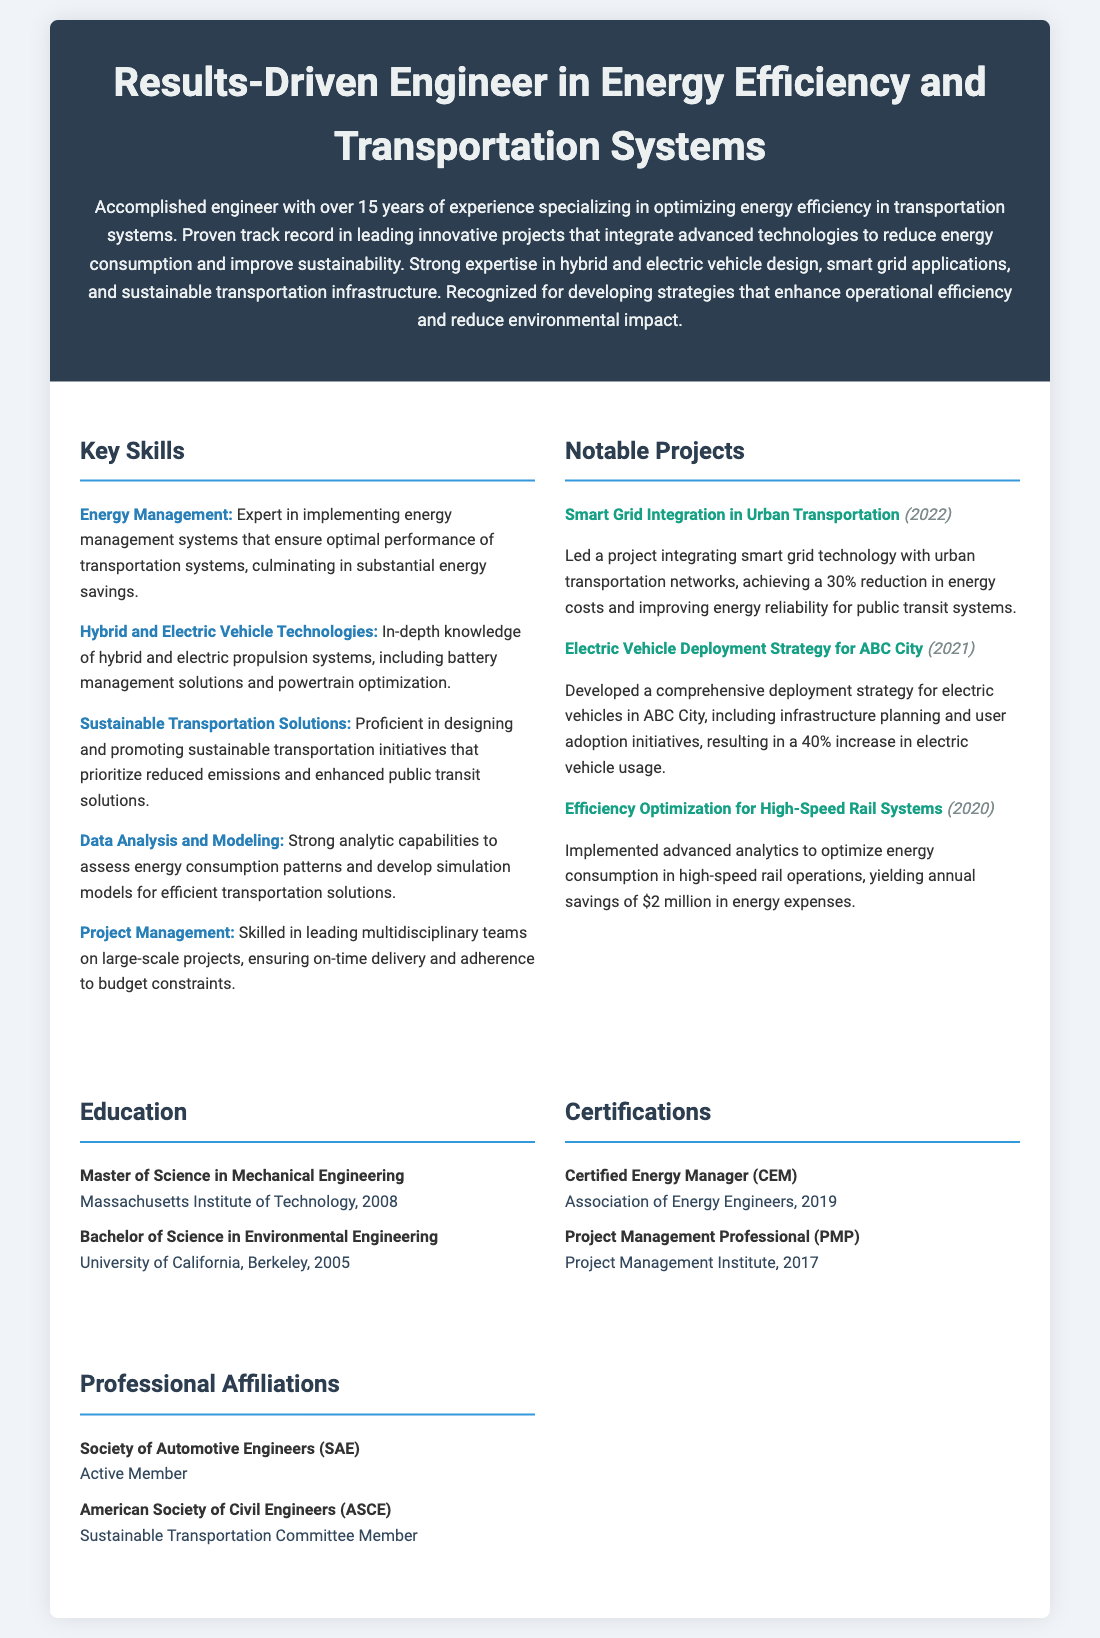what is the title of the CV? The title of the CV is prominently displayed at the top, reflecting the individual's expertise and focus areas.
Answer: Results-Driven Engineer in Energy Efficiency and Transportation Systems how many years of experience does the engineer have? The summary section states that the engineer has over 15 years of experience in their field.
Answer: 15 years which project achieved a 30% reduction in energy costs? The notable projects section lists a project that achieved this energy cost reduction, specifically regarding smart grid technology.
Answer: Smart Grid Integration in Urban Transportation what is one of the key skills listed in the CV? The skills section enumerates various expertise areas, making it easy to identify key skills.
Answer: Energy Management who issued the Certified Energy Manager certification? The certifications section indicates the organization responsible for issuing this certification.
Answer: Association of Energy Engineers in which year did the engineer obtain their Master's degree? The education section specifies the year when the degree was awarded, which can be found alongside the institution name.
Answer: 2008 what was the focus of the efficiency optimization project in 2020? The notable projects section describes this project, detailing its aims within the context of transportation systems.
Answer: High-Speed Rail Systems what role does the engineer hold in the American Society of Civil Engineers? The affiliations section outlines the specific roles of the engineer in recognized organizations, including ASCE.
Answer: Sustainable Transportation Committee Member 